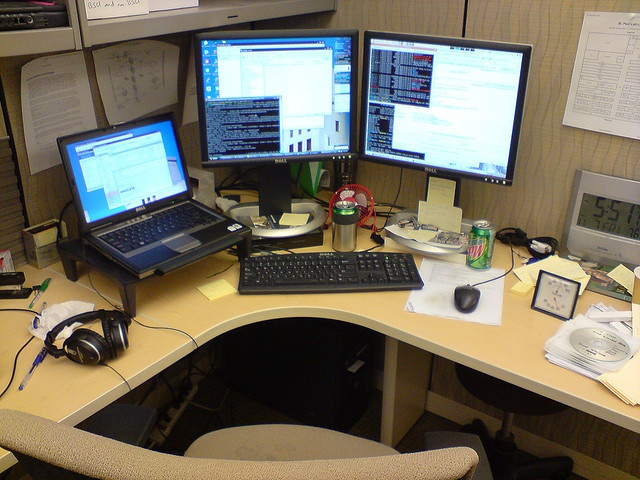Describe the objects in this image and their specific colors. I can see tv in black, white, navy, and gray tones, laptop in black, lightblue, and navy tones, chair in black, tan, and gray tones, keyboard in black, darkgreen, and gray tones, and clock in black, gray, and darkgreen tones in this image. 